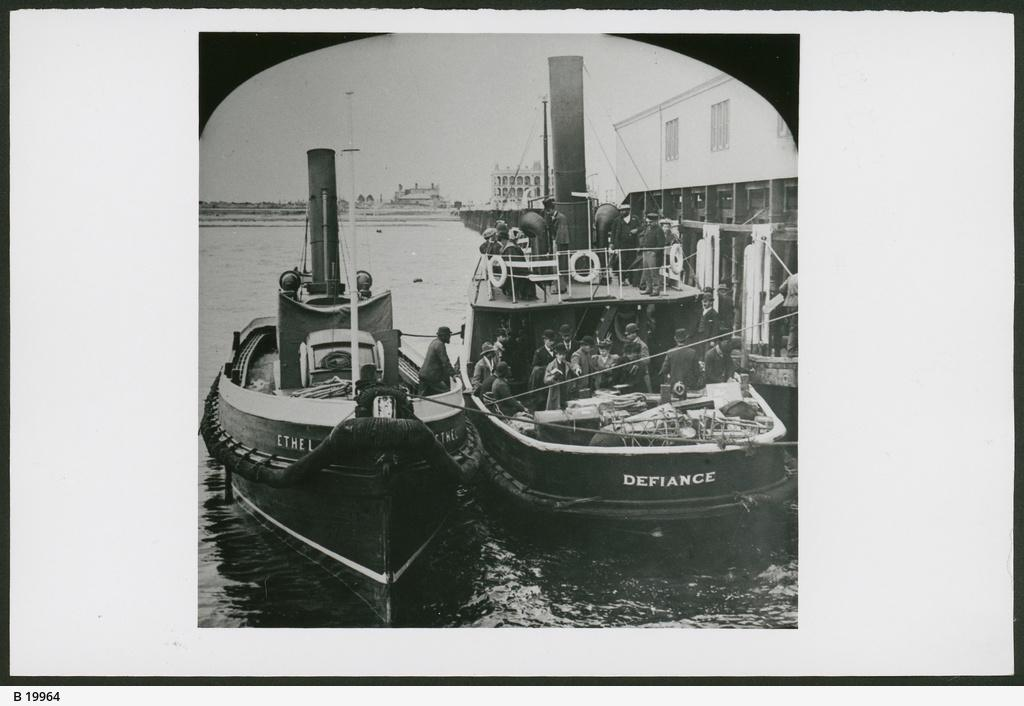What can be observed about the editing of the image? The image is edited. What is the main subject of the black and white picture in the image? There is a black and white picture of two ships in the image. Where are the ships located in the image? The ships are on the water surface in the image. Are there any people present in the ships? Yes, there are people in the ships. What type of cheese is being served on the ships in the image? There is no cheese present in the image; it features a black and white picture of two ships with people on them. 